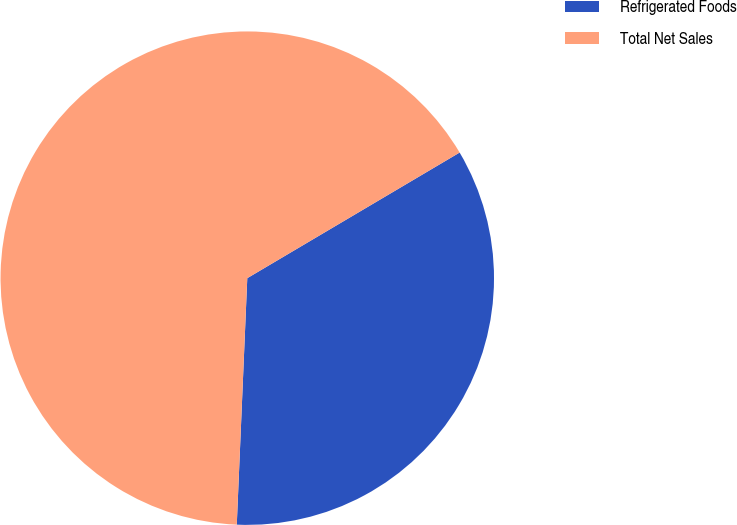<chart> <loc_0><loc_0><loc_500><loc_500><pie_chart><fcel>Refrigerated Foods<fcel>Total Net Sales<nl><fcel>34.18%<fcel>65.82%<nl></chart> 